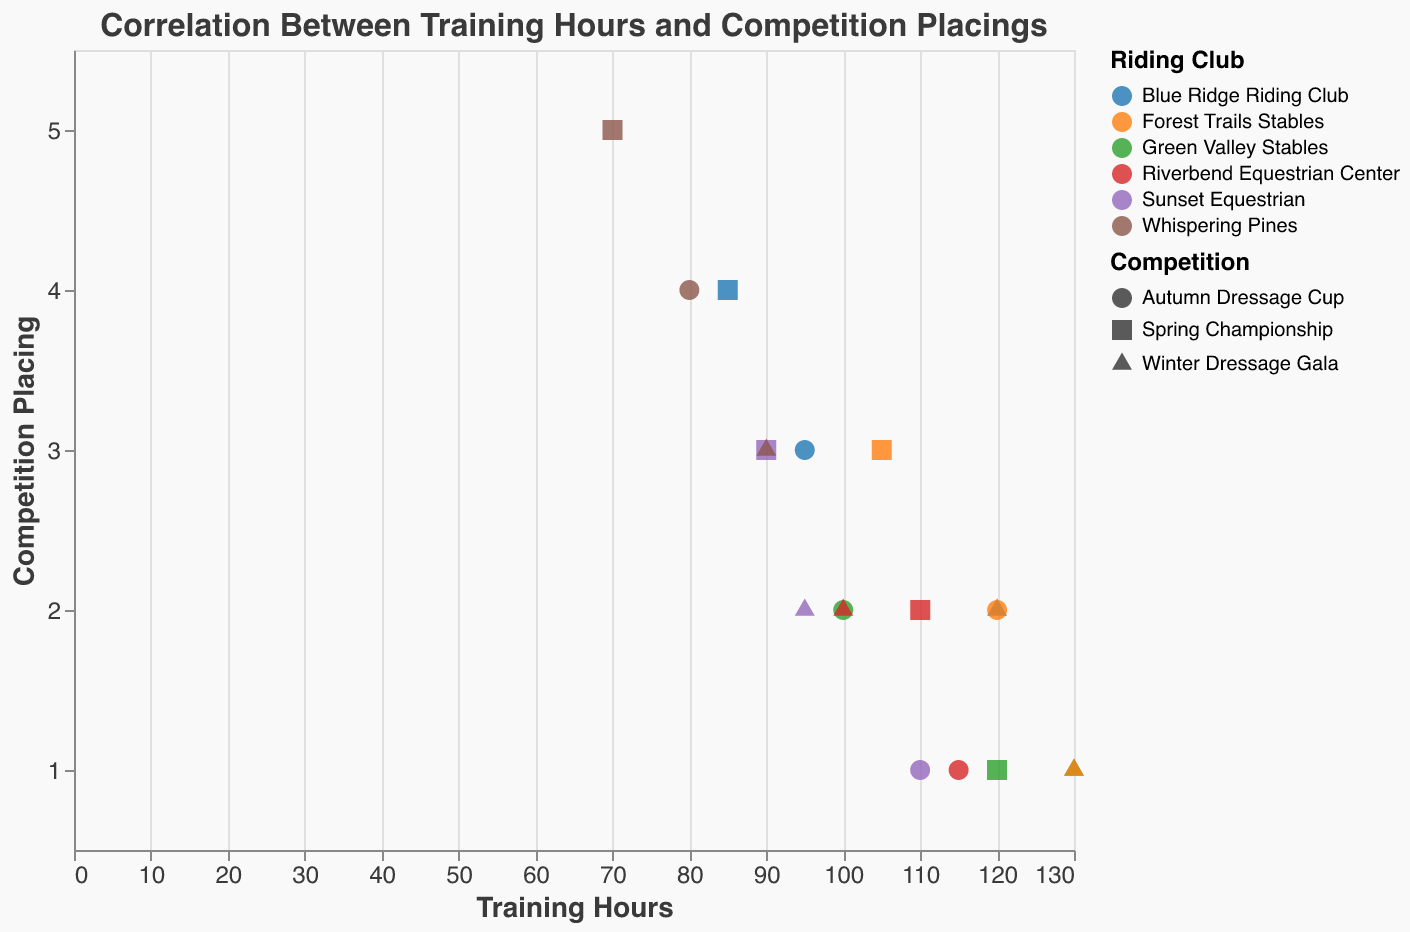What is the title of the chart? The title can be found at the top of the chart. It is usually set to describe the purpose or content of the chart.
Answer: Correlation Between Training Hours and Competition Placings What does the x-axis represent? The x-axis typically has a label to indicate what it represents. In this chart, it is labeled as "Training Hours."
Answer: Training hours What does the y-axis represent? The y-axis usually has a label indicating what it represents. In this chart, it is labeled as "Competition Placing."
Answer: Competition placing Which club had the most training hours for the Winter Dressage Gala? Locate the points associated with the Winter Dressage Gala (different shapes for each competition) and find the highest value on the x-axis. For the Winter Dressage Gala competition, a triangle shape represents different clubs.
Answer: Green Valley Stables and Forest Trails Stables (130 hours each) What is the average placing for Riverbend Equestrian Center? Identify the points representing Riverbend Equestrian Center and read their y-values. Calculate the average (2 + 1 + 2)/3.
Answer: 1.67 Which club had the lowest placing and how many training hours did they have? Find the lowest y-value (placing) and read off the corresponding x-value (training hours). The lowest placing is the first place.
Answer: Green Valley Stables and Forest Trails Stables (both had 130 hours) Which competition had the most hours of training put in, on average, across all clubs? Find all points for each competition type (shape) and calculate the average training hours for each type. Compare these averages to determine which is the highest.
Answer: Winter Dressage Gala Compare Training Hours and Placings for "Green Valley Stables" and "Sunset Equestrian" in the Spring Championship. Identify the points for both clubs in the Spring Championship and compare the `Training_Hours` and `Placing` values. Green Valley Stables has 120 training hours with a 1st place, while Sunset Equestrian has 90 training hours with a 3rd place.
Answer: Green Valley Stables has more training hours and a better placing compared to Sunset Equestrian For how many competitions did Blue Ridge Riding Club achieve a placing of 3 or better? Identify the points for Blue Ridge Riding Club and count those that have y-values of 3 or below.
Answer: 2 competitions Which club generally had the least training hours across all competitions? Sum up or average the training hours for each club across all competitions and identify which club has the smallest value. Adding all training hours for each club and comparing might help.
Answer: Whispering Pines 